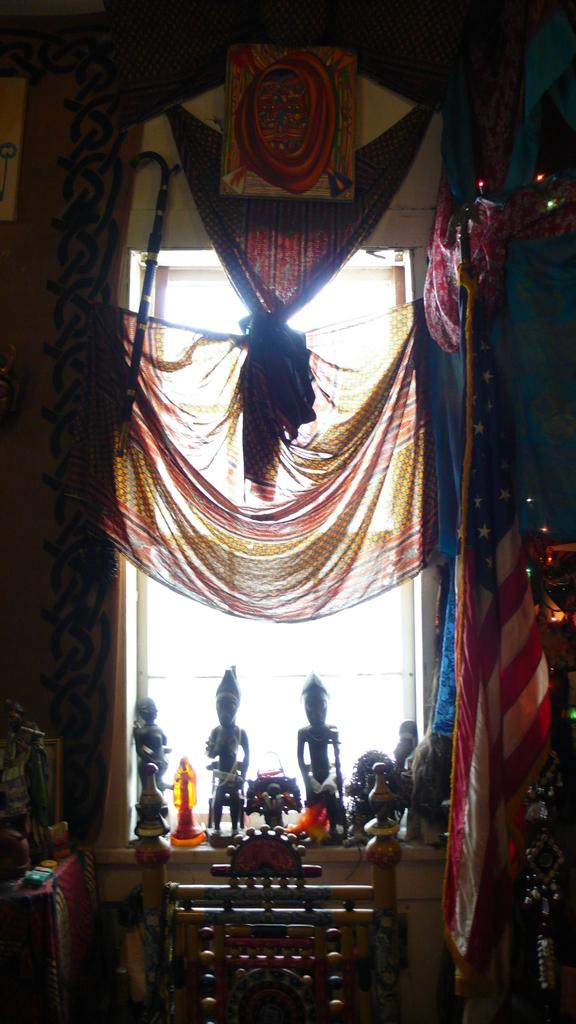What objects are in the foreground of the image? In the foreground of the image, there are cloths, curtains, sculptures, and a chair. Can you describe the objects in the foreground in more detail? The cloths and curtains are likely fabric-based, while the sculptures are three-dimensional art pieces. The chair appears to be a piece of furniture. What is visible on the left side of the image? There is a wall on the left side of the image. What nation is represented by the chess pieces on the table in the image? There are no chess pieces or a table present in the image. What is the nature of the argument between the two individuals in the image? There are no individuals or an argument present in the image. 